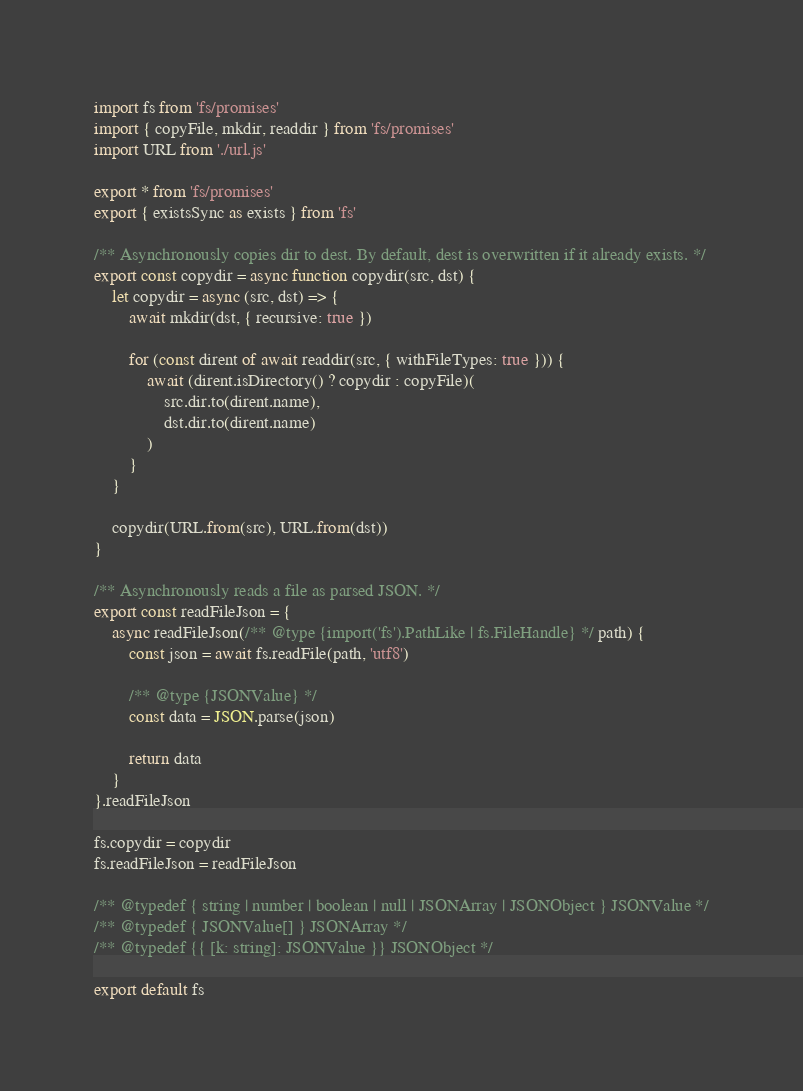<code> <loc_0><loc_0><loc_500><loc_500><_JavaScript_>import fs from 'fs/promises'
import { copyFile, mkdir, readdir } from 'fs/promises'
import URL from './url.js'

export * from 'fs/promises'
export { existsSync as exists } from 'fs'

/** Asynchronously copies dir to dest. By default, dest is overwritten if it already exists. */
export const copydir = async function copydir(src, dst) {
	let copydir = async (src, dst) => {
		await mkdir(dst, { recursive: true })

		for (const dirent of await readdir(src, { withFileTypes: true })) {
			await (dirent.isDirectory() ? copydir : copyFile)(
				src.dir.to(dirent.name),
				dst.dir.to(dirent.name)
			)
		}
	}

	copydir(URL.from(src), URL.from(dst))
}

/** Asynchronously reads a file as parsed JSON. */
export const readFileJson = {
	async readFileJson(/** @type {import('fs').PathLike | fs.FileHandle} */ path) {
		const json = await fs.readFile(path, 'utf8')

		/** @type {JSONValue} */
		const data = JSON.parse(json)

		return data
	}
}.readFileJson

fs.copydir = copydir
fs.readFileJson = readFileJson

/** @typedef { string | number | boolean | null | JSONArray | JSONObject } JSONValue */
/** @typedef { JSONValue[] } JSONArray */
/** @typedef {{ [k: string]: JSONValue }} JSONObject */

export default fs
</code> 